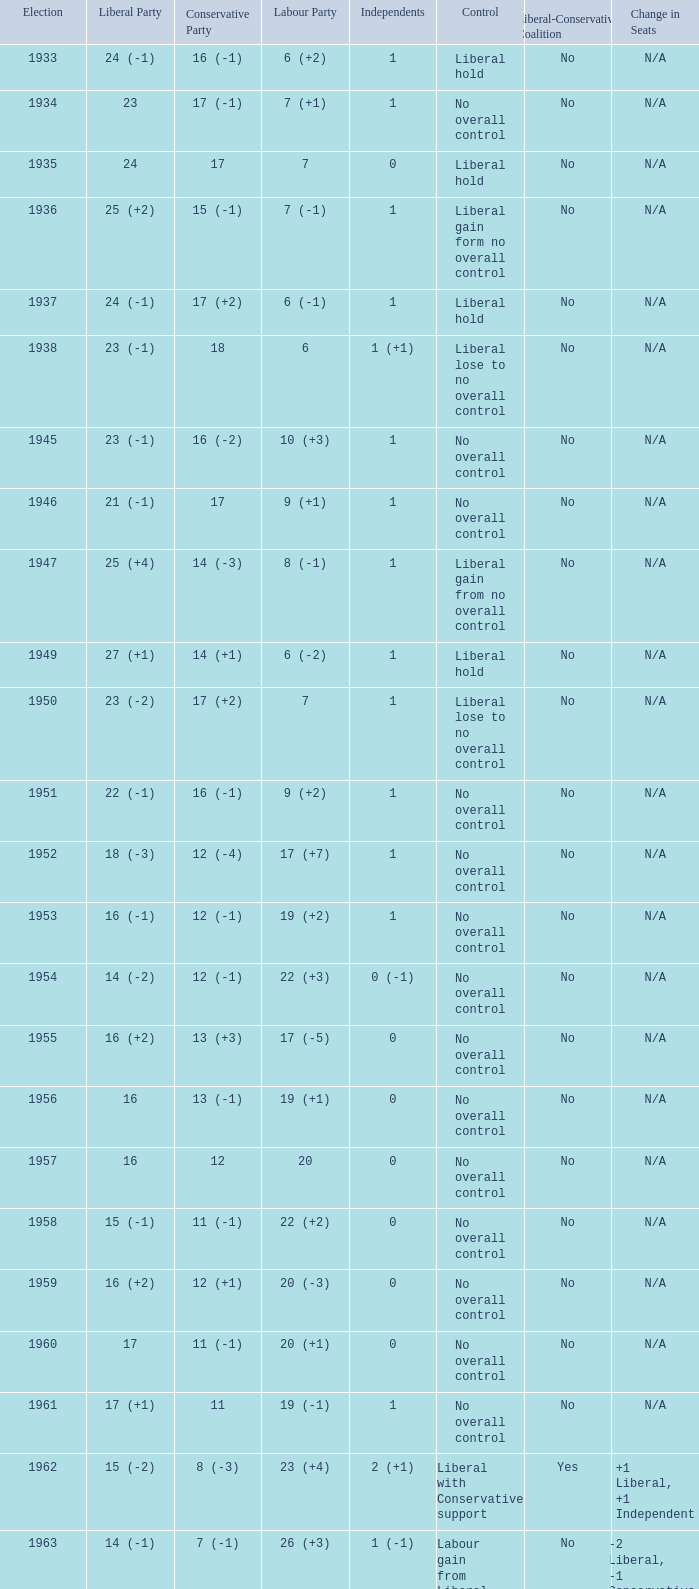What was the liberal party outcome in the election with a conservative party outcome of 16 (-1) and labour of 6 (+2)? 24 (-1). 